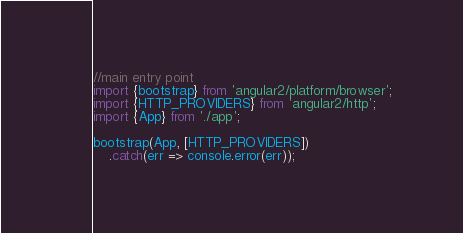<code> <loc_0><loc_0><loc_500><loc_500><_TypeScript_>//main entry point
import {bootstrap} from 'angular2/platform/browser';
import {HTTP_PROVIDERS} from 'angular2/http';
import {App} from './app';

bootstrap(App, [HTTP_PROVIDERS])
    .catch(err => console.error(err));
</code> 